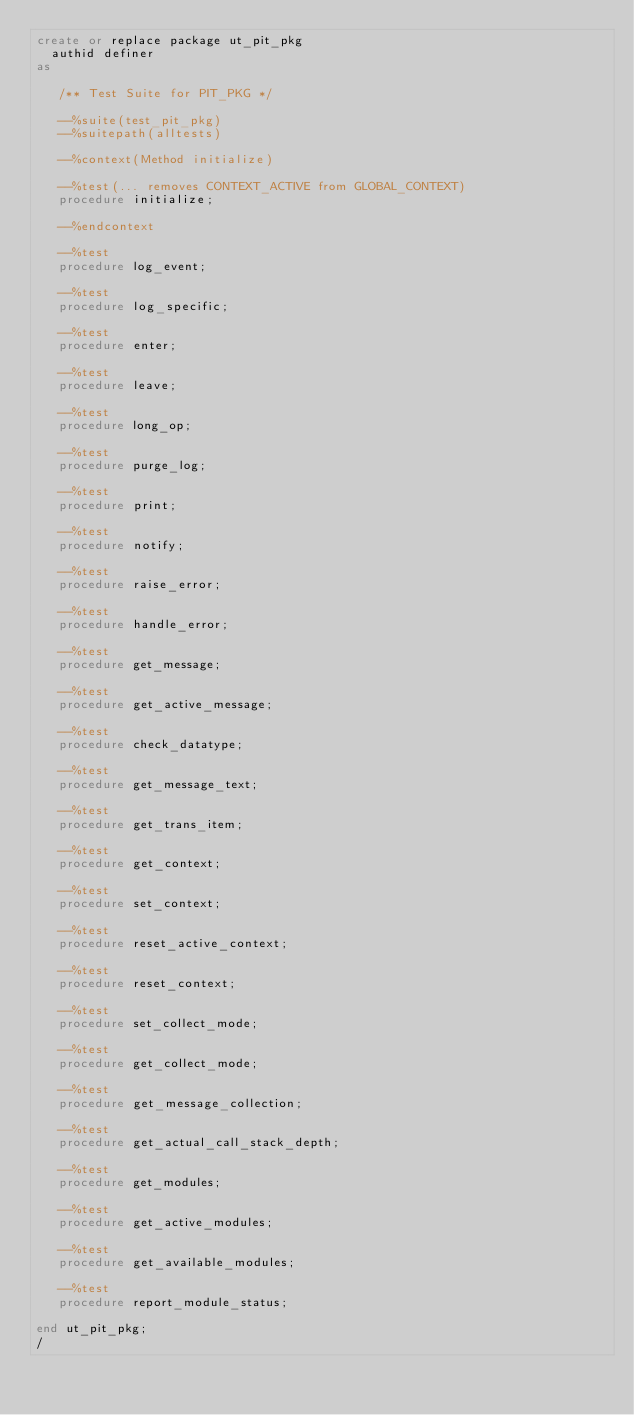<code> <loc_0><loc_0><loc_500><loc_500><_SQL_>create or replace package ut_pit_pkg 
  authid definer
as

   /** Test Suite for PIT_PKG */

   --%suite(test_pit_pkg)
   --%suitepath(alltests)
   
   --%context(Method initialize)

   --%test(... removes CONTEXT_ACTIVE from GLOBAL_CONTEXT)
   procedure initialize;
   
   --%endcontext

   --%test
   procedure log_event;

   --%test
   procedure log_specific;

   --%test
   procedure enter;

   --%test
   procedure leave;

   --%test
   procedure long_op;

   --%test
   procedure purge_log;

   --%test
   procedure print;

   --%test
   procedure notify;

   --%test
   procedure raise_error;

   --%test
   procedure handle_error;

   --%test
   procedure get_message;

   --%test
   procedure get_active_message;

   --%test
   procedure check_datatype;

   --%test
   procedure get_message_text;

   --%test
   procedure get_trans_item;

   --%test
   procedure get_context;

   --%test
   procedure set_context;

   --%test
   procedure reset_active_context;

   --%test
   procedure reset_context;

   --%test
   procedure set_collect_mode;

   --%test
   procedure get_collect_mode;

   --%test
   procedure get_message_collection;

   --%test
   procedure get_actual_call_stack_depth;

   --%test
   procedure get_modules;

   --%test
   procedure get_active_modules;

   --%test
   procedure get_available_modules;

   --%test
   procedure report_module_status;

end ut_pit_pkg;
/
</code> 